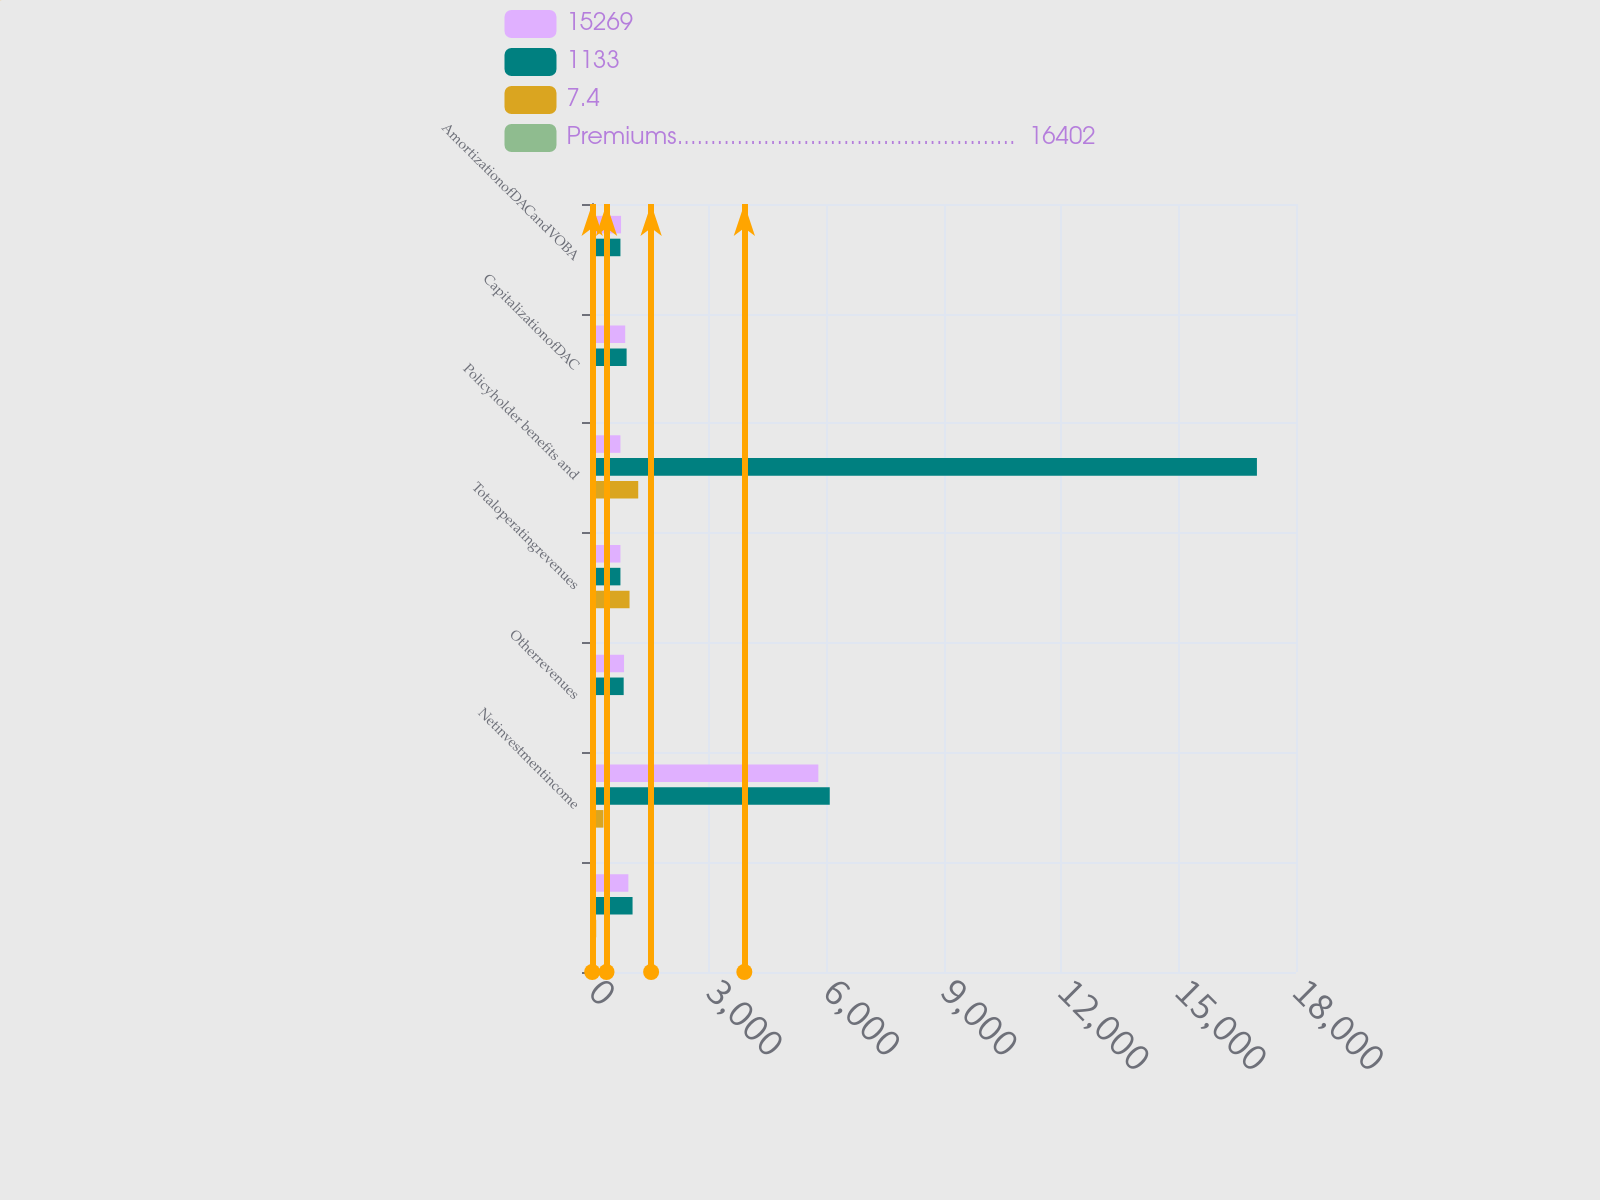Convert chart to OTSL. <chart><loc_0><loc_0><loc_500><loc_500><stacked_bar_chart><ecel><fcel>Unnamed: 1<fcel>Netinvestmentincome<fcel>Otherrevenues<fcel>Totaloperatingrevenues<fcel>Policyholder benefits and<fcel>CapitalizationofDAC<fcel>AmortizationofDACandVOBA<nl><fcel>15269<fcel>930<fcel>5787<fcel>819<fcel>727<fcel>727<fcel>849<fcel>743<nl><fcel>1133<fcel>1037<fcel>6079<fcel>810<fcel>727<fcel>17001<fcel>885<fcel>727<nl><fcel>7.4<fcel>107<fcel>292<fcel>9<fcel>960<fcel>1182<fcel>36<fcel>16<nl><fcel>Premiums...................................................  16402<fcel>10.3<fcel>4.8<fcel>1.1<fcel>4<fcel>7<fcel>4.1<fcel>2.2<nl></chart> 